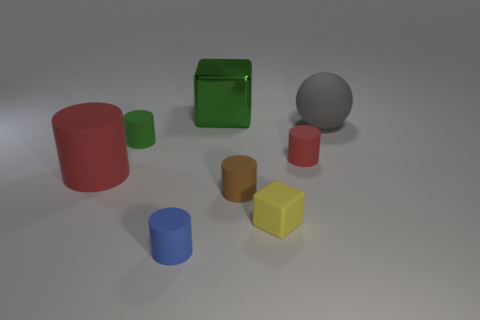Subtract all blue matte cylinders. How many cylinders are left? 4 Add 2 tiny blue rubber things. How many objects exist? 10 Subtract all brown cylinders. How many cylinders are left? 4 Subtract all blue spheres. How many red cylinders are left? 2 Subtract 3 cylinders. How many cylinders are left? 2 Subtract all spheres. How many objects are left? 7 Add 5 small red objects. How many small red objects are left? 6 Add 7 large cylinders. How many large cylinders exist? 8 Subtract 0 yellow balls. How many objects are left? 8 Subtract all gray cylinders. Subtract all green balls. How many cylinders are left? 5 